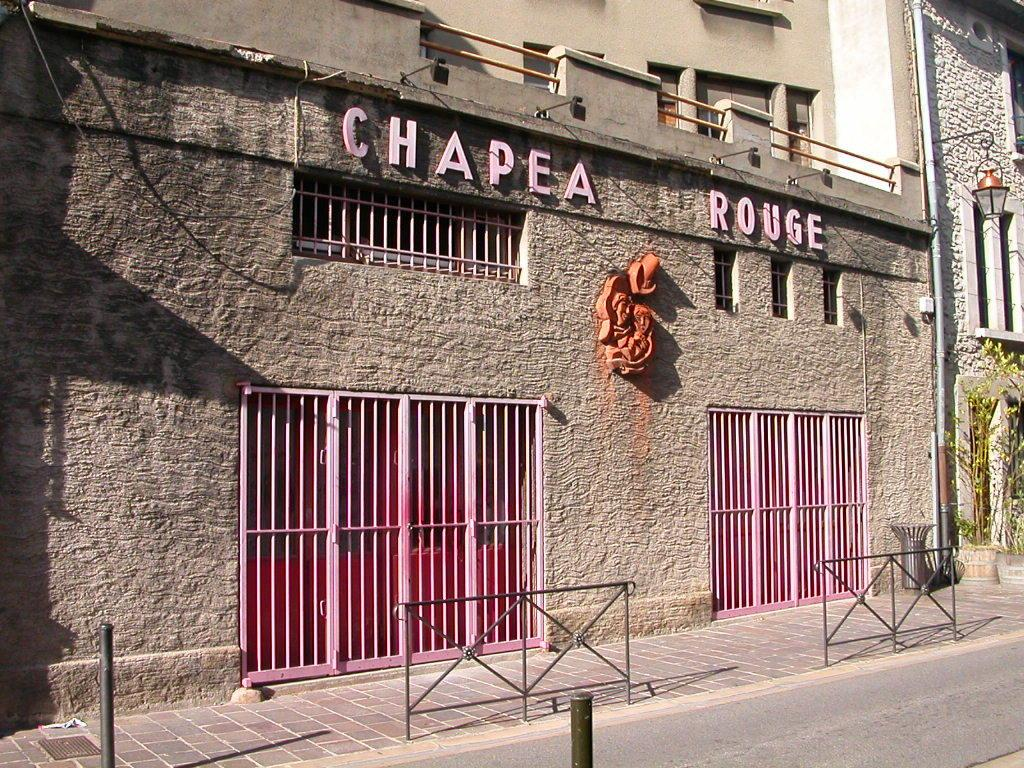What type of structures can be seen in the image? There are buildings with windows in the image. Can you describe any specific features of the buildings? The buildings have windows. What other objects can be seen in the image? There is a pipe, a lamp, plants, a footpath, a wall, poles, and a road in the image. Are there any unidentified objects in the image? Yes, there are some unspecified objects in the image. What color is the calculator on the wall in the image? There is no calculator present in the image. How tall are the giants walking on the footpath in the image? There are no giants present in the image. 